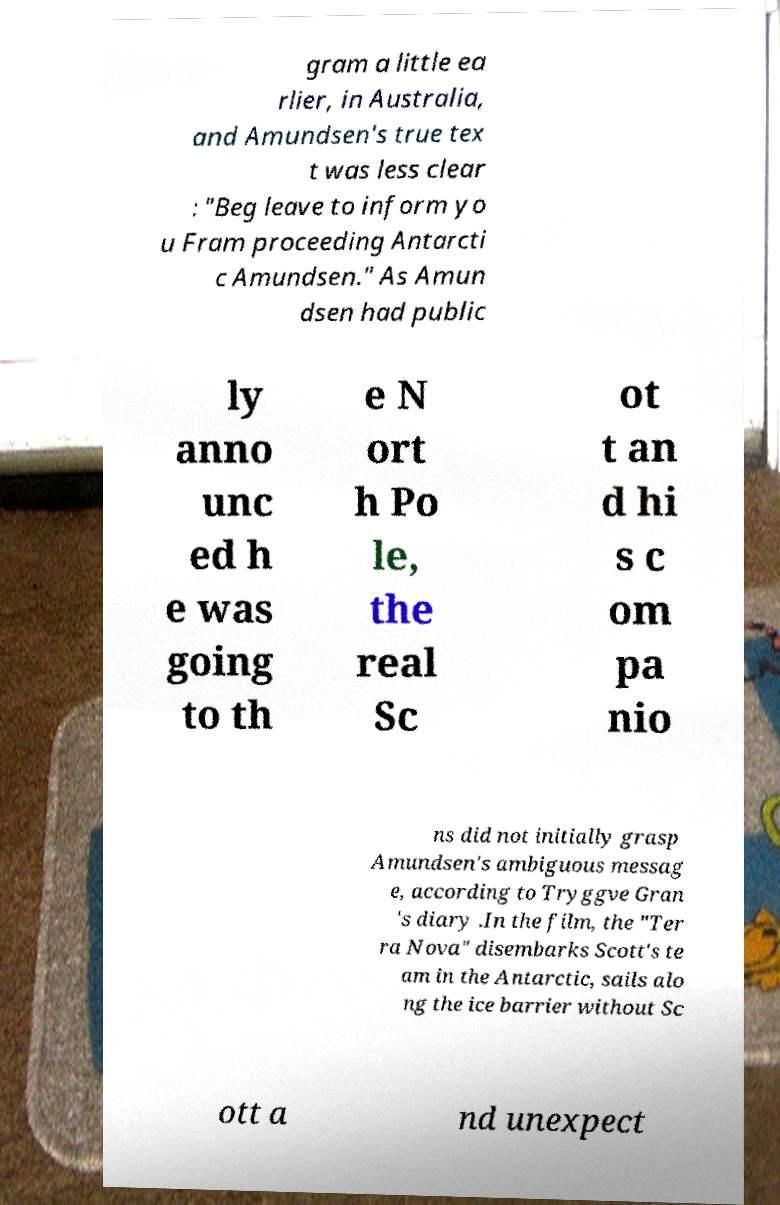Could you extract and type out the text from this image? gram a little ea rlier, in Australia, and Amundsen's true tex t was less clear : "Beg leave to inform yo u Fram proceeding Antarcti c Amundsen." As Amun dsen had public ly anno unc ed h e was going to th e N ort h Po le, the real Sc ot t an d hi s c om pa nio ns did not initially grasp Amundsen's ambiguous messag e, according to Tryggve Gran 's diary .In the film, the "Ter ra Nova" disembarks Scott's te am in the Antarctic, sails alo ng the ice barrier without Sc ott a nd unexpect 